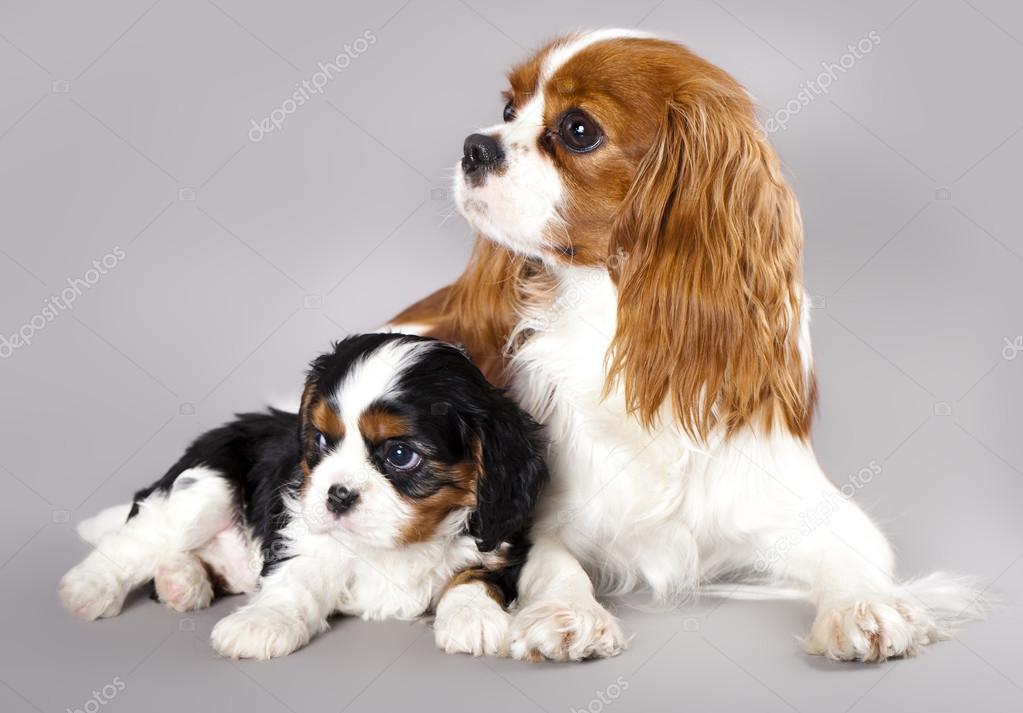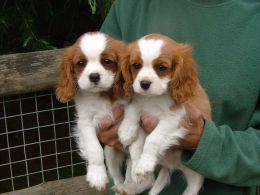The first image is the image on the left, the second image is the image on the right. For the images displayed, is the sentence "One image features exactly two puppies, one brown and white, and the other black, brown and white." factually correct? Answer yes or no. Yes. The first image is the image on the left, the second image is the image on the right. For the images displayed, is the sentence "There are no more than four cocker spaniels" factually correct? Answer yes or no. Yes. 